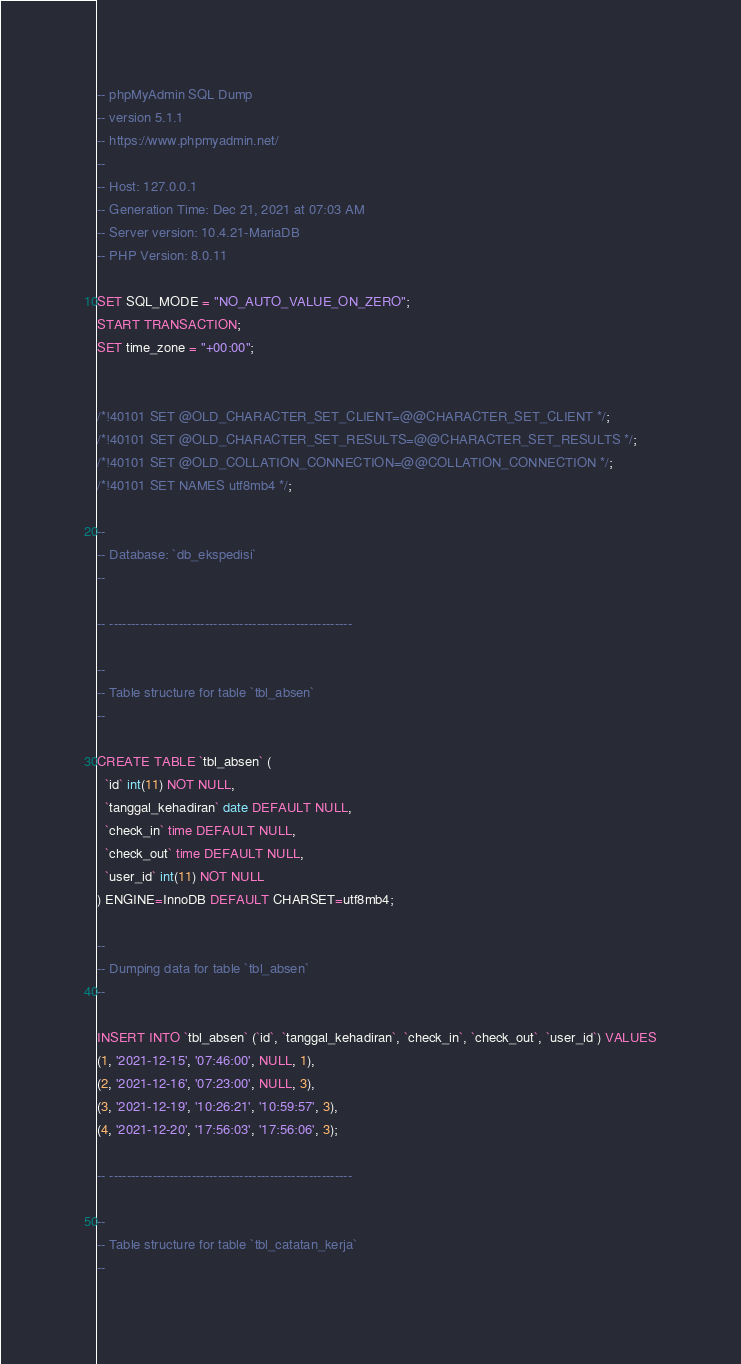Convert code to text. <code><loc_0><loc_0><loc_500><loc_500><_SQL_>-- phpMyAdmin SQL Dump
-- version 5.1.1
-- https://www.phpmyadmin.net/
--
-- Host: 127.0.0.1
-- Generation Time: Dec 21, 2021 at 07:03 AM
-- Server version: 10.4.21-MariaDB
-- PHP Version: 8.0.11

SET SQL_MODE = "NO_AUTO_VALUE_ON_ZERO";
START TRANSACTION;
SET time_zone = "+00:00";


/*!40101 SET @OLD_CHARACTER_SET_CLIENT=@@CHARACTER_SET_CLIENT */;
/*!40101 SET @OLD_CHARACTER_SET_RESULTS=@@CHARACTER_SET_RESULTS */;
/*!40101 SET @OLD_COLLATION_CONNECTION=@@COLLATION_CONNECTION */;
/*!40101 SET NAMES utf8mb4 */;

--
-- Database: `db_ekspedisi`
--

-- --------------------------------------------------------

--
-- Table structure for table `tbl_absen`
--

CREATE TABLE `tbl_absen` (
  `id` int(11) NOT NULL,
  `tanggal_kehadiran` date DEFAULT NULL,
  `check_in` time DEFAULT NULL,
  `check_out` time DEFAULT NULL,
  `user_id` int(11) NOT NULL
) ENGINE=InnoDB DEFAULT CHARSET=utf8mb4;

--
-- Dumping data for table `tbl_absen`
--

INSERT INTO `tbl_absen` (`id`, `tanggal_kehadiran`, `check_in`, `check_out`, `user_id`) VALUES
(1, '2021-12-15', '07:46:00', NULL, 1),
(2, '2021-12-16', '07:23:00', NULL, 3),
(3, '2021-12-19', '10:26:21', '10:59:57', 3),
(4, '2021-12-20', '17:56:03', '17:56:06', 3);

-- --------------------------------------------------------

--
-- Table structure for table `tbl_catatan_kerja`
--
</code> 